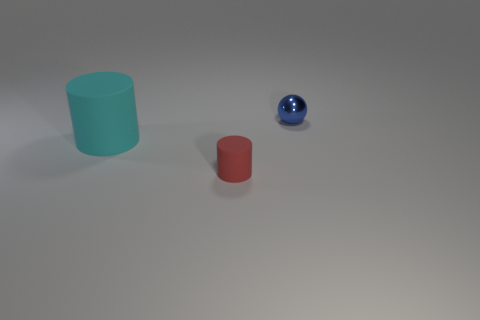Can you describe the lighting in the scene? The lighting in the scene appears to be soft and diffused, with no harsh shadows, suggesting an overall gentle illumination possibly from a source not visible in the image. 